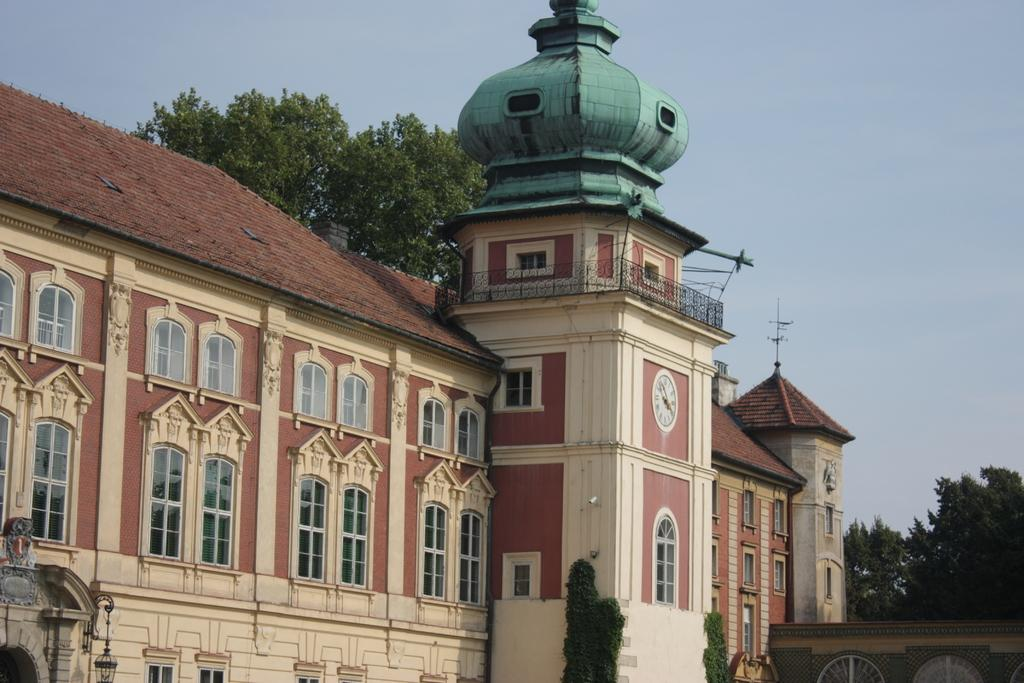What type of structure is present in the image? There is a building in the image. What other natural elements can be seen in the image? There are trees in the image. What part of the environment is visible in the image? The sky is visible in the image. How many bikes are parked in the bath in the image? There is no bath or bikes present in the image. 